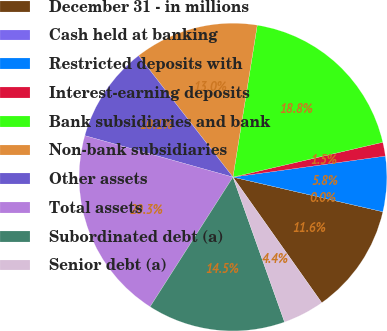Convert chart to OTSL. <chart><loc_0><loc_0><loc_500><loc_500><pie_chart><fcel>December 31 - in millions<fcel>Cash held at banking<fcel>Restricted deposits with<fcel>Interest-earning deposits<fcel>Bank subsidiaries and bank<fcel>Non-bank subsidiaries<fcel>Other assets<fcel>Total assets<fcel>Subordinated debt (a)<fcel>Senior debt (a)<nl><fcel>11.59%<fcel>0.0%<fcel>5.8%<fcel>1.45%<fcel>18.84%<fcel>13.04%<fcel>10.14%<fcel>20.29%<fcel>14.49%<fcel>4.35%<nl></chart> 